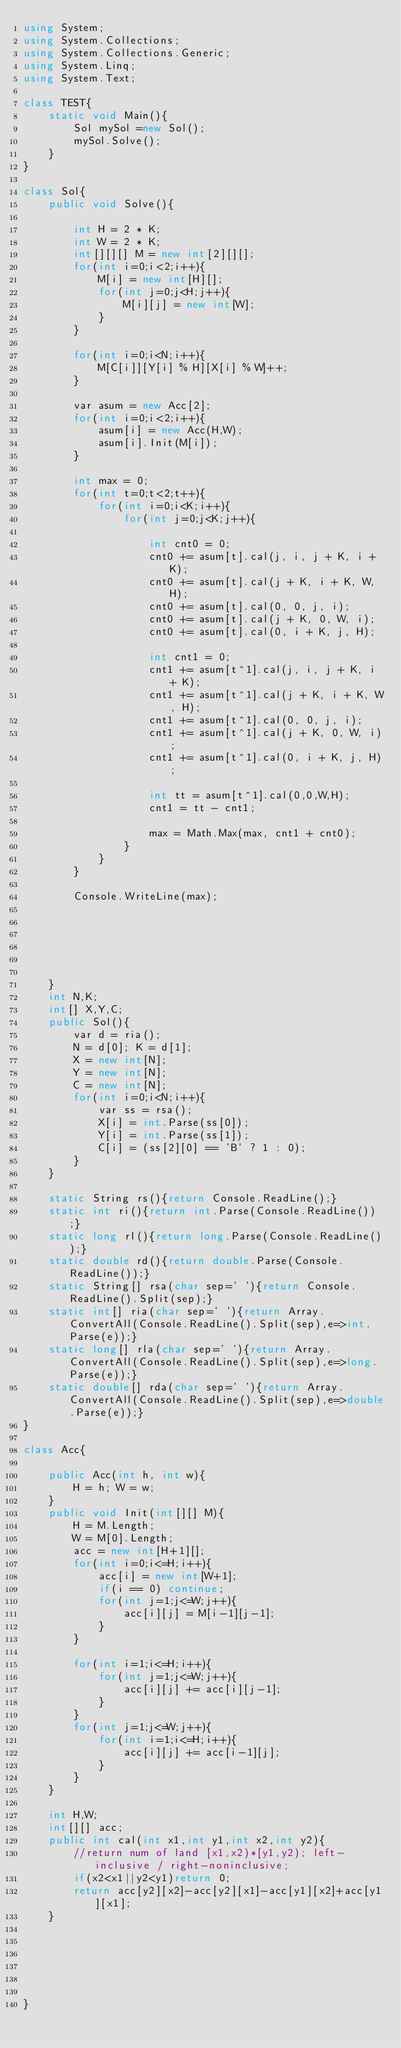Convert code to text. <code><loc_0><loc_0><loc_500><loc_500><_C#_>using System;
using System.Collections;
using System.Collections.Generic;
using System.Linq;
using System.Text;

class TEST{
	static void Main(){
		Sol mySol =new Sol();
		mySol.Solve();
	}
}

class Sol{
	public void Solve(){
		
		int H = 2 * K;
		int W = 2 * K;
		int[][][] M = new int[2][][];
		for(int i=0;i<2;i++){
			M[i] = new int[H][];
			for(int j=0;j<H;j++){
				M[i][j] = new int[W];
			}
		}
		
		for(int i=0;i<N;i++){
			M[C[i]][Y[i] % H][X[i] % W]++;
		}
		
		var asum = new Acc[2];
		for(int i=0;i<2;i++){
			asum[i] = new Acc(H,W);
			asum[i].Init(M[i]);
		}
		
		int max = 0;
		for(int t=0;t<2;t++){
			for(int i=0;i<K;i++){
				for(int j=0;j<K;j++){
					
					int cnt0 = 0;
					cnt0 += asum[t].cal(j, i, j + K, i + K);
					cnt0 += asum[t].cal(j + K, i + K, W, H);
					cnt0 += asum[t].cal(0, 0, j, i);
					cnt0 += asum[t].cal(j + K, 0, W, i);
					cnt0 += asum[t].cal(0, i + K, j, H);
					
					int cnt1 = 0;
					cnt1 += asum[t^1].cal(j, i, j + K, i + K);
					cnt1 += asum[t^1].cal(j + K, i + K, W, H);
					cnt1 += asum[t^1].cal(0, 0, j, i);
					cnt1 += asum[t^1].cal(j + K, 0, W, i);
					cnt1 += asum[t^1].cal(0, i + K, j, H);
					
					int tt = asum[t^1].cal(0,0,W,H);
					cnt1 = tt - cnt1;
					
					max = Math.Max(max, cnt1 + cnt0);
				}
			}
		}
		
		Console.WriteLine(max);
		
		
		
		
		
		
	}
	int N,K;
	int[] X,Y,C;
	public Sol(){
		var d = ria();
		N = d[0]; K = d[1];
		X = new int[N];
		Y = new int[N];
		C = new int[N];
		for(int i=0;i<N;i++){
			var ss = rsa();
			X[i] = int.Parse(ss[0]);
			Y[i] = int.Parse(ss[1]);
			C[i] = (ss[2][0] == 'B' ? 1 : 0);
		}
	}

	static String rs(){return Console.ReadLine();}
	static int ri(){return int.Parse(Console.ReadLine());}
	static long rl(){return long.Parse(Console.ReadLine());}
	static double rd(){return double.Parse(Console.ReadLine());}
	static String[] rsa(char sep=' '){return Console.ReadLine().Split(sep);}
	static int[] ria(char sep=' '){return Array.ConvertAll(Console.ReadLine().Split(sep),e=>int.Parse(e));}
	static long[] rla(char sep=' '){return Array.ConvertAll(Console.ReadLine().Split(sep),e=>long.Parse(e));}
	static double[] rda(char sep=' '){return Array.ConvertAll(Console.ReadLine().Split(sep),e=>double.Parse(e));}
}

class Acc{

	public Acc(int h, int w){
		H = h; W = w;
	}
	public void Init(int[][] M){
		H = M.Length;
		W = M[0].Length;
		acc = new int[H+1][];
		for(int i=0;i<=H;i++){
			acc[i] = new int[W+1];
			if(i == 0) continue;
			for(int j=1;j<=W;j++){
				acc[i][j] = M[i-1][j-1];
			}
		}
		
		for(int i=1;i<=H;i++){
			for(int j=1;j<=W;j++){
				acc[i][j] += acc[i][j-1];
			}
		}
		for(int j=1;j<=W;j++){
			for(int i=1;i<=H;i++){
				acc[i][j] += acc[i-1][j];
			}
		}
	}
	
	int H,W;
	int[][] acc;
	public int cal(int x1,int y1,int x2,int y2){
		//return num of land [x1,x2)*[y1,y2); left-inclusive / right-noninclusive;
		if(x2<x1||y2<y1)return 0;
		return acc[y2][x2]-acc[y2][x1]-acc[y1][x2]+acc[y1][x1];
	}
	





}</code> 